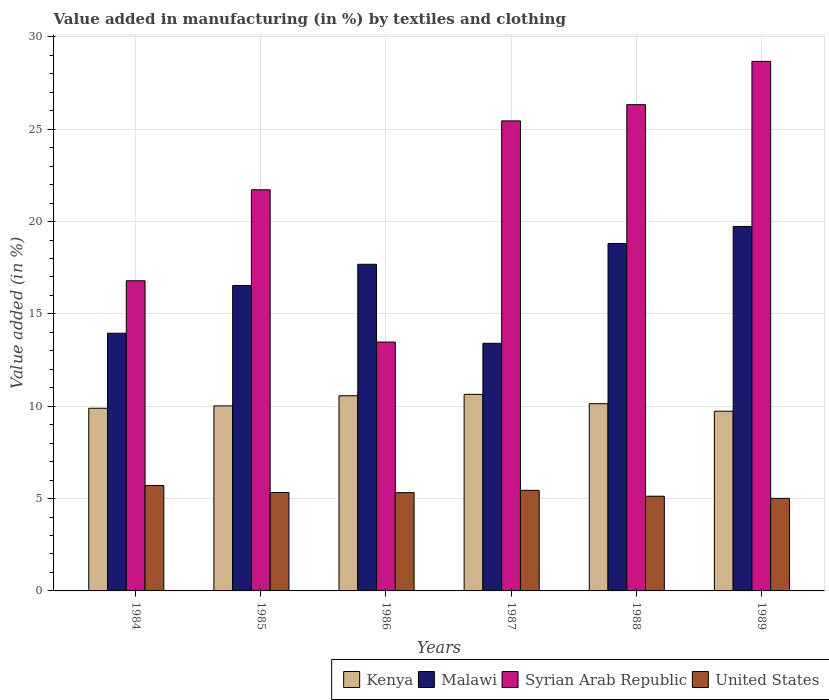How many different coloured bars are there?
Your answer should be very brief. 4. Are the number of bars per tick equal to the number of legend labels?
Your answer should be very brief. Yes. How many bars are there on the 4th tick from the left?
Provide a short and direct response. 4. How many bars are there on the 3rd tick from the right?
Your answer should be very brief. 4. What is the label of the 2nd group of bars from the left?
Provide a short and direct response. 1985. What is the percentage of value added in manufacturing by textiles and clothing in Malawi in 1987?
Your answer should be compact. 13.41. Across all years, what is the maximum percentage of value added in manufacturing by textiles and clothing in United States?
Offer a very short reply. 5.71. Across all years, what is the minimum percentage of value added in manufacturing by textiles and clothing in United States?
Provide a succinct answer. 5.01. In which year was the percentage of value added in manufacturing by textiles and clothing in Syrian Arab Republic maximum?
Give a very brief answer. 1989. In which year was the percentage of value added in manufacturing by textiles and clothing in Malawi minimum?
Offer a very short reply. 1987. What is the total percentage of value added in manufacturing by textiles and clothing in Malawi in the graph?
Ensure brevity in your answer.  100.14. What is the difference between the percentage of value added in manufacturing by textiles and clothing in United States in 1987 and that in 1988?
Ensure brevity in your answer.  0.32. What is the difference between the percentage of value added in manufacturing by textiles and clothing in Syrian Arab Republic in 1987 and the percentage of value added in manufacturing by textiles and clothing in Malawi in 1985?
Offer a terse response. 8.92. What is the average percentage of value added in manufacturing by textiles and clothing in Syrian Arab Republic per year?
Your answer should be very brief. 22.08. In the year 1985, what is the difference between the percentage of value added in manufacturing by textiles and clothing in Syrian Arab Republic and percentage of value added in manufacturing by textiles and clothing in United States?
Your answer should be compact. 16.39. In how many years, is the percentage of value added in manufacturing by textiles and clothing in Kenya greater than 26 %?
Offer a terse response. 0. What is the ratio of the percentage of value added in manufacturing by textiles and clothing in Kenya in 1986 to that in 1987?
Offer a terse response. 0.99. Is the difference between the percentage of value added in manufacturing by textiles and clothing in Syrian Arab Republic in 1984 and 1989 greater than the difference between the percentage of value added in manufacturing by textiles and clothing in United States in 1984 and 1989?
Your response must be concise. No. What is the difference between the highest and the second highest percentage of value added in manufacturing by textiles and clothing in Kenya?
Keep it short and to the point. 0.07. What is the difference between the highest and the lowest percentage of value added in manufacturing by textiles and clothing in Malawi?
Provide a succinct answer. 6.33. In how many years, is the percentage of value added in manufacturing by textiles and clothing in Kenya greater than the average percentage of value added in manufacturing by textiles and clothing in Kenya taken over all years?
Offer a very short reply. 2. Is the sum of the percentage of value added in manufacturing by textiles and clothing in Kenya in 1984 and 1988 greater than the maximum percentage of value added in manufacturing by textiles and clothing in Malawi across all years?
Provide a short and direct response. Yes. Is it the case that in every year, the sum of the percentage of value added in manufacturing by textiles and clothing in Kenya and percentage of value added in manufacturing by textiles and clothing in United States is greater than the sum of percentage of value added in manufacturing by textiles and clothing in Syrian Arab Republic and percentage of value added in manufacturing by textiles and clothing in Malawi?
Make the answer very short. Yes. What does the 2nd bar from the left in 1985 represents?
Your response must be concise. Malawi. What does the 3rd bar from the right in 1984 represents?
Keep it short and to the point. Malawi. Are all the bars in the graph horizontal?
Provide a short and direct response. No. How many years are there in the graph?
Your answer should be compact. 6. What is the difference between two consecutive major ticks on the Y-axis?
Provide a succinct answer. 5. Does the graph contain grids?
Offer a very short reply. Yes. How many legend labels are there?
Give a very brief answer. 4. How are the legend labels stacked?
Make the answer very short. Horizontal. What is the title of the graph?
Provide a short and direct response. Value added in manufacturing (in %) by textiles and clothing. What is the label or title of the X-axis?
Provide a short and direct response. Years. What is the label or title of the Y-axis?
Offer a very short reply. Value added (in %). What is the Value added (in %) of Kenya in 1984?
Ensure brevity in your answer.  9.89. What is the Value added (in %) in Malawi in 1984?
Your answer should be compact. 13.95. What is the Value added (in %) of Syrian Arab Republic in 1984?
Keep it short and to the point. 16.8. What is the Value added (in %) in United States in 1984?
Keep it short and to the point. 5.71. What is the Value added (in %) in Kenya in 1985?
Offer a terse response. 10.02. What is the Value added (in %) in Malawi in 1985?
Your answer should be compact. 16.54. What is the Value added (in %) of Syrian Arab Republic in 1985?
Keep it short and to the point. 21.72. What is the Value added (in %) in United States in 1985?
Ensure brevity in your answer.  5.33. What is the Value added (in %) of Kenya in 1986?
Your answer should be very brief. 10.57. What is the Value added (in %) of Malawi in 1986?
Your answer should be compact. 17.69. What is the Value added (in %) of Syrian Arab Republic in 1986?
Provide a succinct answer. 13.48. What is the Value added (in %) in United States in 1986?
Ensure brevity in your answer.  5.32. What is the Value added (in %) of Kenya in 1987?
Provide a succinct answer. 10.64. What is the Value added (in %) of Malawi in 1987?
Make the answer very short. 13.41. What is the Value added (in %) in Syrian Arab Republic in 1987?
Ensure brevity in your answer.  25.45. What is the Value added (in %) in United States in 1987?
Ensure brevity in your answer.  5.45. What is the Value added (in %) of Kenya in 1988?
Keep it short and to the point. 10.14. What is the Value added (in %) in Malawi in 1988?
Provide a short and direct response. 18.81. What is the Value added (in %) in Syrian Arab Republic in 1988?
Give a very brief answer. 26.33. What is the Value added (in %) of United States in 1988?
Ensure brevity in your answer.  5.13. What is the Value added (in %) in Kenya in 1989?
Ensure brevity in your answer.  9.73. What is the Value added (in %) of Malawi in 1989?
Your answer should be very brief. 19.74. What is the Value added (in %) in Syrian Arab Republic in 1989?
Your answer should be very brief. 28.68. What is the Value added (in %) of United States in 1989?
Keep it short and to the point. 5.01. Across all years, what is the maximum Value added (in %) of Kenya?
Give a very brief answer. 10.64. Across all years, what is the maximum Value added (in %) in Malawi?
Provide a short and direct response. 19.74. Across all years, what is the maximum Value added (in %) of Syrian Arab Republic?
Give a very brief answer. 28.68. Across all years, what is the maximum Value added (in %) of United States?
Your answer should be very brief. 5.71. Across all years, what is the minimum Value added (in %) of Kenya?
Give a very brief answer. 9.73. Across all years, what is the minimum Value added (in %) of Malawi?
Make the answer very short. 13.41. Across all years, what is the minimum Value added (in %) in Syrian Arab Republic?
Provide a succinct answer. 13.48. Across all years, what is the minimum Value added (in %) of United States?
Provide a short and direct response. 5.01. What is the total Value added (in %) of Kenya in the graph?
Your response must be concise. 60.99. What is the total Value added (in %) of Malawi in the graph?
Make the answer very short. 100.14. What is the total Value added (in %) in Syrian Arab Republic in the graph?
Make the answer very short. 132.45. What is the total Value added (in %) in United States in the graph?
Ensure brevity in your answer.  31.95. What is the difference between the Value added (in %) in Kenya in 1984 and that in 1985?
Your response must be concise. -0.13. What is the difference between the Value added (in %) in Malawi in 1984 and that in 1985?
Keep it short and to the point. -2.58. What is the difference between the Value added (in %) in Syrian Arab Republic in 1984 and that in 1985?
Provide a short and direct response. -4.93. What is the difference between the Value added (in %) in United States in 1984 and that in 1985?
Your answer should be compact. 0.38. What is the difference between the Value added (in %) of Kenya in 1984 and that in 1986?
Offer a very short reply. -0.68. What is the difference between the Value added (in %) of Malawi in 1984 and that in 1986?
Your answer should be very brief. -3.73. What is the difference between the Value added (in %) in Syrian Arab Republic in 1984 and that in 1986?
Keep it short and to the point. 3.32. What is the difference between the Value added (in %) in United States in 1984 and that in 1986?
Your response must be concise. 0.39. What is the difference between the Value added (in %) in Kenya in 1984 and that in 1987?
Your answer should be compact. -0.75. What is the difference between the Value added (in %) of Malawi in 1984 and that in 1987?
Provide a short and direct response. 0.55. What is the difference between the Value added (in %) in Syrian Arab Republic in 1984 and that in 1987?
Your answer should be compact. -8.66. What is the difference between the Value added (in %) in United States in 1984 and that in 1987?
Your answer should be compact. 0.26. What is the difference between the Value added (in %) of Kenya in 1984 and that in 1988?
Make the answer very short. -0.25. What is the difference between the Value added (in %) in Malawi in 1984 and that in 1988?
Make the answer very short. -4.86. What is the difference between the Value added (in %) in Syrian Arab Republic in 1984 and that in 1988?
Your answer should be compact. -9.53. What is the difference between the Value added (in %) in United States in 1984 and that in 1988?
Make the answer very short. 0.58. What is the difference between the Value added (in %) in Kenya in 1984 and that in 1989?
Give a very brief answer. 0.16. What is the difference between the Value added (in %) in Malawi in 1984 and that in 1989?
Ensure brevity in your answer.  -5.78. What is the difference between the Value added (in %) in Syrian Arab Republic in 1984 and that in 1989?
Your answer should be compact. -11.88. What is the difference between the Value added (in %) in United States in 1984 and that in 1989?
Offer a very short reply. 0.7. What is the difference between the Value added (in %) of Kenya in 1985 and that in 1986?
Keep it short and to the point. -0.55. What is the difference between the Value added (in %) in Malawi in 1985 and that in 1986?
Offer a terse response. -1.15. What is the difference between the Value added (in %) in Syrian Arab Republic in 1985 and that in 1986?
Keep it short and to the point. 8.24. What is the difference between the Value added (in %) of United States in 1985 and that in 1986?
Offer a terse response. 0.01. What is the difference between the Value added (in %) in Kenya in 1985 and that in 1987?
Offer a terse response. -0.62. What is the difference between the Value added (in %) in Malawi in 1985 and that in 1987?
Ensure brevity in your answer.  3.13. What is the difference between the Value added (in %) of Syrian Arab Republic in 1985 and that in 1987?
Keep it short and to the point. -3.73. What is the difference between the Value added (in %) of United States in 1985 and that in 1987?
Keep it short and to the point. -0.12. What is the difference between the Value added (in %) of Kenya in 1985 and that in 1988?
Make the answer very short. -0.12. What is the difference between the Value added (in %) of Malawi in 1985 and that in 1988?
Offer a very short reply. -2.28. What is the difference between the Value added (in %) in Syrian Arab Republic in 1985 and that in 1988?
Your answer should be compact. -4.61. What is the difference between the Value added (in %) in United States in 1985 and that in 1988?
Keep it short and to the point. 0.2. What is the difference between the Value added (in %) in Kenya in 1985 and that in 1989?
Your response must be concise. 0.29. What is the difference between the Value added (in %) in Malawi in 1985 and that in 1989?
Your answer should be compact. -3.2. What is the difference between the Value added (in %) of Syrian Arab Republic in 1985 and that in 1989?
Ensure brevity in your answer.  -6.96. What is the difference between the Value added (in %) of United States in 1985 and that in 1989?
Your answer should be very brief. 0.32. What is the difference between the Value added (in %) in Kenya in 1986 and that in 1987?
Provide a succinct answer. -0.07. What is the difference between the Value added (in %) in Malawi in 1986 and that in 1987?
Provide a succinct answer. 4.28. What is the difference between the Value added (in %) of Syrian Arab Republic in 1986 and that in 1987?
Offer a terse response. -11.98. What is the difference between the Value added (in %) in United States in 1986 and that in 1987?
Provide a short and direct response. -0.13. What is the difference between the Value added (in %) in Kenya in 1986 and that in 1988?
Give a very brief answer. 0.43. What is the difference between the Value added (in %) of Malawi in 1986 and that in 1988?
Keep it short and to the point. -1.13. What is the difference between the Value added (in %) of Syrian Arab Republic in 1986 and that in 1988?
Your answer should be very brief. -12.85. What is the difference between the Value added (in %) of United States in 1986 and that in 1988?
Provide a succinct answer. 0.19. What is the difference between the Value added (in %) in Kenya in 1986 and that in 1989?
Give a very brief answer. 0.84. What is the difference between the Value added (in %) of Malawi in 1986 and that in 1989?
Offer a very short reply. -2.05. What is the difference between the Value added (in %) in Syrian Arab Republic in 1986 and that in 1989?
Your response must be concise. -15.2. What is the difference between the Value added (in %) in United States in 1986 and that in 1989?
Your answer should be very brief. 0.31. What is the difference between the Value added (in %) in Kenya in 1987 and that in 1988?
Provide a short and direct response. 0.51. What is the difference between the Value added (in %) of Malawi in 1987 and that in 1988?
Ensure brevity in your answer.  -5.4. What is the difference between the Value added (in %) of Syrian Arab Republic in 1987 and that in 1988?
Keep it short and to the point. -0.88. What is the difference between the Value added (in %) of United States in 1987 and that in 1988?
Give a very brief answer. 0.32. What is the difference between the Value added (in %) of Kenya in 1987 and that in 1989?
Provide a short and direct response. 0.91. What is the difference between the Value added (in %) of Malawi in 1987 and that in 1989?
Keep it short and to the point. -6.33. What is the difference between the Value added (in %) of Syrian Arab Republic in 1987 and that in 1989?
Your answer should be compact. -3.22. What is the difference between the Value added (in %) in United States in 1987 and that in 1989?
Offer a terse response. 0.43. What is the difference between the Value added (in %) in Kenya in 1988 and that in 1989?
Your response must be concise. 0.41. What is the difference between the Value added (in %) in Malawi in 1988 and that in 1989?
Your answer should be very brief. -0.92. What is the difference between the Value added (in %) of Syrian Arab Republic in 1988 and that in 1989?
Give a very brief answer. -2.35. What is the difference between the Value added (in %) of United States in 1988 and that in 1989?
Make the answer very short. 0.12. What is the difference between the Value added (in %) in Kenya in 1984 and the Value added (in %) in Malawi in 1985?
Provide a succinct answer. -6.65. What is the difference between the Value added (in %) in Kenya in 1984 and the Value added (in %) in Syrian Arab Republic in 1985?
Your answer should be very brief. -11.83. What is the difference between the Value added (in %) of Kenya in 1984 and the Value added (in %) of United States in 1985?
Your answer should be very brief. 4.56. What is the difference between the Value added (in %) in Malawi in 1984 and the Value added (in %) in Syrian Arab Republic in 1985?
Provide a short and direct response. -7.77. What is the difference between the Value added (in %) in Malawi in 1984 and the Value added (in %) in United States in 1985?
Your answer should be compact. 8.62. What is the difference between the Value added (in %) of Syrian Arab Republic in 1984 and the Value added (in %) of United States in 1985?
Your response must be concise. 11.47. What is the difference between the Value added (in %) in Kenya in 1984 and the Value added (in %) in Malawi in 1986?
Ensure brevity in your answer.  -7.8. What is the difference between the Value added (in %) of Kenya in 1984 and the Value added (in %) of Syrian Arab Republic in 1986?
Your answer should be compact. -3.58. What is the difference between the Value added (in %) of Kenya in 1984 and the Value added (in %) of United States in 1986?
Provide a short and direct response. 4.57. What is the difference between the Value added (in %) in Malawi in 1984 and the Value added (in %) in Syrian Arab Republic in 1986?
Make the answer very short. 0.48. What is the difference between the Value added (in %) in Malawi in 1984 and the Value added (in %) in United States in 1986?
Ensure brevity in your answer.  8.63. What is the difference between the Value added (in %) in Syrian Arab Republic in 1984 and the Value added (in %) in United States in 1986?
Keep it short and to the point. 11.48. What is the difference between the Value added (in %) of Kenya in 1984 and the Value added (in %) of Malawi in 1987?
Your response must be concise. -3.52. What is the difference between the Value added (in %) of Kenya in 1984 and the Value added (in %) of Syrian Arab Republic in 1987?
Give a very brief answer. -15.56. What is the difference between the Value added (in %) of Kenya in 1984 and the Value added (in %) of United States in 1987?
Offer a very short reply. 4.45. What is the difference between the Value added (in %) in Malawi in 1984 and the Value added (in %) in Syrian Arab Republic in 1987?
Offer a terse response. -11.5. What is the difference between the Value added (in %) in Malawi in 1984 and the Value added (in %) in United States in 1987?
Keep it short and to the point. 8.51. What is the difference between the Value added (in %) of Syrian Arab Republic in 1984 and the Value added (in %) of United States in 1987?
Offer a terse response. 11.35. What is the difference between the Value added (in %) in Kenya in 1984 and the Value added (in %) in Malawi in 1988?
Provide a succinct answer. -8.92. What is the difference between the Value added (in %) in Kenya in 1984 and the Value added (in %) in Syrian Arab Republic in 1988?
Your answer should be very brief. -16.44. What is the difference between the Value added (in %) of Kenya in 1984 and the Value added (in %) of United States in 1988?
Your response must be concise. 4.76. What is the difference between the Value added (in %) of Malawi in 1984 and the Value added (in %) of Syrian Arab Republic in 1988?
Offer a terse response. -12.38. What is the difference between the Value added (in %) of Malawi in 1984 and the Value added (in %) of United States in 1988?
Offer a terse response. 8.83. What is the difference between the Value added (in %) in Syrian Arab Republic in 1984 and the Value added (in %) in United States in 1988?
Ensure brevity in your answer.  11.67. What is the difference between the Value added (in %) in Kenya in 1984 and the Value added (in %) in Malawi in 1989?
Give a very brief answer. -9.84. What is the difference between the Value added (in %) in Kenya in 1984 and the Value added (in %) in Syrian Arab Republic in 1989?
Keep it short and to the point. -18.78. What is the difference between the Value added (in %) in Kenya in 1984 and the Value added (in %) in United States in 1989?
Ensure brevity in your answer.  4.88. What is the difference between the Value added (in %) in Malawi in 1984 and the Value added (in %) in Syrian Arab Republic in 1989?
Your response must be concise. -14.72. What is the difference between the Value added (in %) of Malawi in 1984 and the Value added (in %) of United States in 1989?
Offer a terse response. 8.94. What is the difference between the Value added (in %) of Syrian Arab Republic in 1984 and the Value added (in %) of United States in 1989?
Keep it short and to the point. 11.78. What is the difference between the Value added (in %) in Kenya in 1985 and the Value added (in %) in Malawi in 1986?
Give a very brief answer. -7.67. What is the difference between the Value added (in %) of Kenya in 1985 and the Value added (in %) of Syrian Arab Republic in 1986?
Offer a very short reply. -3.46. What is the difference between the Value added (in %) in Kenya in 1985 and the Value added (in %) in United States in 1986?
Offer a terse response. 4.7. What is the difference between the Value added (in %) in Malawi in 1985 and the Value added (in %) in Syrian Arab Republic in 1986?
Make the answer very short. 3.06. What is the difference between the Value added (in %) in Malawi in 1985 and the Value added (in %) in United States in 1986?
Offer a terse response. 11.22. What is the difference between the Value added (in %) of Syrian Arab Republic in 1985 and the Value added (in %) of United States in 1986?
Your answer should be very brief. 16.4. What is the difference between the Value added (in %) in Kenya in 1985 and the Value added (in %) in Malawi in 1987?
Provide a short and direct response. -3.39. What is the difference between the Value added (in %) in Kenya in 1985 and the Value added (in %) in Syrian Arab Republic in 1987?
Ensure brevity in your answer.  -15.43. What is the difference between the Value added (in %) in Kenya in 1985 and the Value added (in %) in United States in 1987?
Provide a succinct answer. 4.57. What is the difference between the Value added (in %) of Malawi in 1985 and the Value added (in %) of Syrian Arab Republic in 1987?
Offer a very short reply. -8.92. What is the difference between the Value added (in %) of Malawi in 1985 and the Value added (in %) of United States in 1987?
Your response must be concise. 11.09. What is the difference between the Value added (in %) of Syrian Arab Republic in 1985 and the Value added (in %) of United States in 1987?
Your answer should be very brief. 16.28. What is the difference between the Value added (in %) of Kenya in 1985 and the Value added (in %) of Malawi in 1988?
Offer a terse response. -8.79. What is the difference between the Value added (in %) of Kenya in 1985 and the Value added (in %) of Syrian Arab Republic in 1988?
Offer a terse response. -16.31. What is the difference between the Value added (in %) of Kenya in 1985 and the Value added (in %) of United States in 1988?
Your answer should be compact. 4.89. What is the difference between the Value added (in %) of Malawi in 1985 and the Value added (in %) of Syrian Arab Republic in 1988?
Your answer should be compact. -9.79. What is the difference between the Value added (in %) in Malawi in 1985 and the Value added (in %) in United States in 1988?
Your answer should be very brief. 11.41. What is the difference between the Value added (in %) of Syrian Arab Republic in 1985 and the Value added (in %) of United States in 1988?
Your response must be concise. 16.59. What is the difference between the Value added (in %) in Kenya in 1985 and the Value added (in %) in Malawi in 1989?
Give a very brief answer. -9.72. What is the difference between the Value added (in %) of Kenya in 1985 and the Value added (in %) of Syrian Arab Republic in 1989?
Keep it short and to the point. -18.66. What is the difference between the Value added (in %) of Kenya in 1985 and the Value added (in %) of United States in 1989?
Provide a short and direct response. 5.01. What is the difference between the Value added (in %) in Malawi in 1985 and the Value added (in %) in Syrian Arab Republic in 1989?
Provide a short and direct response. -12.14. What is the difference between the Value added (in %) in Malawi in 1985 and the Value added (in %) in United States in 1989?
Your answer should be compact. 11.53. What is the difference between the Value added (in %) of Syrian Arab Republic in 1985 and the Value added (in %) of United States in 1989?
Offer a very short reply. 16.71. What is the difference between the Value added (in %) in Kenya in 1986 and the Value added (in %) in Malawi in 1987?
Make the answer very short. -2.84. What is the difference between the Value added (in %) in Kenya in 1986 and the Value added (in %) in Syrian Arab Republic in 1987?
Your answer should be compact. -14.88. What is the difference between the Value added (in %) in Kenya in 1986 and the Value added (in %) in United States in 1987?
Your response must be concise. 5.12. What is the difference between the Value added (in %) in Malawi in 1986 and the Value added (in %) in Syrian Arab Republic in 1987?
Your answer should be compact. -7.77. What is the difference between the Value added (in %) in Malawi in 1986 and the Value added (in %) in United States in 1987?
Your answer should be very brief. 12.24. What is the difference between the Value added (in %) in Syrian Arab Republic in 1986 and the Value added (in %) in United States in 1987?
Your response must be concise. 8.03. What is the difference between the Value added (in %) of Kenya in 1986 and the Value added (in %) of Malawi in 1988?
Give a very brief answer. -8.24. What is the difference between the Value added (in %) of Kenya in 1986 and the Value added (in %) of Syrian Arab Republic in 1988?
Your answer should be very brief. -15.76. What is the difference between the Value added (in %) of Kenya in 1986 and the Value added (in %) of United States in 1988?
Your response must be concise. 5.44. What is the difference between the Value added (in %) in Malawi in 1986 and the Value added (in %) in Syrian Arab Republic in 1988?
Ensure brevity in your answer.  -8.64. What is the difference between the Value added (in %) in Malawi in 1986 and the Value added (in %) in United States in 1988?
Provide a succinct answer. 12.56. What is the difference between the Value added (in %) of Syrian Arab Republic in 1986 and the Value added (in %) of United States in 1988?
Provide a succinct answer. 8.35. What is the difference between the Value added (in %) in Kenya in 1986 and the Value added (in %) in Malawi in 1989?
Ensure brevity in your answer.  -9.17. What is the difference between the Value added (in %) of Kenya in 1986 and the Value added (in %) of Syrian Arab Republic in 1989?
Provide a short and direct response. -18.11. What is the difference between the Value added (in %) of Kenya in 1986 and the Value added (in %) of United States in 1989?
Offer a terse response. 5.56. What is the difference between the Value added (in %) of Malawi in 1986 and the Value added (in %) of Syrian Arab Republic in 1989?
Keep it short and to the point. -10.99. What is the difference between the Value added (in %) in Malawi in 1986 and the Value added (in %) in United States in 1989?
Provide a succinct answer. 12.68. What is the difference between the Value added (in %) of Syrian Arab Republic in 1986 and the Value added (in %) of United States in 1989?
Give a very brief answer. 8.46. What is the difference between the Value added (in %) in Kenya in 1987 and the Value added (in %) in Malawi in 1988?
Ensure brevity in your answer.  -8.17. What is the difference between the Value added (in %) in Kenya in 1987 and the Value added (in %) in Syrian Arab Republic in 1988?
Provide a short and direct response. -15.69. What is the difference between the Value added (in %) of Kenya in 1987 and the Value added (in %) of United States in 1988?
Your answer should be compact. 5.51. What is the difference between the Value added (in %) in Malawi in 1987 and the Value added (in %) in Syrian Arab Republic in 1988?
Offer a terse response. -12.92. What is the difference between the Value added (in %) of Malawi in 1987 and the Value added (in %) of United States in 1988?
Your answer should be compact. 8.28. What is the difference between the Value added (in %) in Syrian Arab Republic in 1987 and the Value added (in %) in United States in 1988?
Provide a succinct answer. 20.32. What is the difference between the Value added (in %) in Kenya in 1987 and the Value added (in %) in Malawi in 1989?
Provide a short and direct response. -9.09. What is the difference between the Value added (in %) of Kenya in 1987 and the Value added (in %) of Syrian Arab Republic in 1989?
Provide a succinct answer. -18.03. What is the difference between the Value added (in %) in Kenya in 1987 and the Value added (in %) in United States in 1989?
Provide a succinct answer. 5.63. What is the difference between the Value added (in %) of Malawi in 1987 and the Value added (in %) of Syrian Arab Republic in 1989?
Your answer should be very brief. -15.27. What is the difference between the Value added (in %) of Malawi in 1987 and the Value added (in %) of United States in 1989?
Offer a terse response. 8.4. What is the difference between the Value added (in %) in Syrian Arab Republic in 1987 and the Value added (in %) in United States in 1989?
Offer a very short reply. 20.44. What is the difference between the Value added (in %) of Kenya in 1988 and the Value added (in %) of Malawi in 1989?
Ensure brevity in your answer.  -9.6. What is the difference between the Value added (in %) of Kenya in 1988 and the Value added (in %) of Syrian Arab Republic in 1989?
Provide a succinct answer. -18.54. What is the difference between the Value added (in %) of Kenya in 1988 and the Value added (in %) of United States in 1989?
Provide a succinct answer. 5.13. What is the difference between the Value added (in %) of Malawi in 1988 and the Value added (in %) of Syrian Arab Republic in 1989?
Provide a short and direct response. -9.86. What is the difference between the Value added (in %) of Malawi in 1988 and the Value added (in %) of United States in 1989?
Keep it short and to the point. 13.8. What is the difference between the Value added (in %) of Syrian Arab Republic in 1988 and the Value added (in %) of United States in 1989?
Make the answer very short. 21.32. What is the average Value added (in %) of Kenya per year?
Offer a very short reply. 10.17. What is the average Value added (in %) of Malawi per year?
Your answer should be compact. 16.69. What is the average Value added (in %) of Syrian Arab Republic per year?
Your response must be concise. 22.08. What is the average Value added (in %) of United States per year?
Your response must be concise. 5.32. In the year 1984, what is the difference between the Value added (in %) in Kenya and Value added (in %) in Malawi?
Your answer should be compact. -4.06. In the year 1984, what is the difference between the Value added (in %) in Kenya and Value added (in %) in Syrian Arab Republic?
Ensure brevity in your answer.  -6.9. In the year 1984, what is the difference between the Value added (in %) of Kenya and Value added (in %) of United States?
Make the answer very short. 4.18. In the year 1984, what is the difference between the Value added (in %) in Malawi and Value added (in %) in Syrian Arab Republic?
Provide a succinct answer. -2.84. In the year 1984, what is the difference between the Value added (in %) of Malawi and Value added (in %) of United States?
Provide a short and direct response. 8.25. In the year 1984, what is the difference between the Value added (in %) of Syrian Arab Republic and Value added (in %) of United States?
Provide a succinct answer. 11.09. In the year 1985, what is the difference between the Value added (in %) in Kenya and Value added (in %) in Malawi?
Make the answer very short. -6.52. In the year 1985, what is the difference between the Value added (in %) of Kenya and Value added (in %) of Syrian Arab Republic?
Offer a very short reply. -11.7. In the year 1985, what is the difference between the Value added (in %) in Kenya and Value added (in %) in United States?
Ensure brevity in your answer.  4.69. In the year 1985, what is the difference between the Value added (in %) in Malawi and Value added (in %) in Syrian Arab Republic?
Provide a succinct answer. -5.18. In the year 1985, what is the difference between the Value added (in %) in Malawi and Value added (in %) in United States?
Make the answer very short. 11.21. In the year 1985, what is the difference between the Value added (in %) of Syrian Arab Republic and Value added (in %) of United States?
Make the answer very short. 16.39. In the year 1986, what is the difference between the Value added (in %) in Kenya and Value added (in %) in Malawi?
Keep it short and to the point. -7.12. In the year 1986, what is the difference between the Value added (in %) of Kenya and Value added (in %) of Syrian Arab Republic?
Offer a terse response. -2.91. In the year 1986, what is the difference between the Value added (in %) in Kenya and Value added (in %) in United States?
Offer a terse response. 5.25. In the year 1986, what is the difference between the Value added (in %) of Malawi and Value added (in %) of Syrian Arab Republic?
Provide a succinct answer. 4.21. In the year 1986, what is the difference between the Value added (in %) of Malawi and Value added (in %) of United States?
Give a very brief answer. 12.37. In the year 1986, what is the difference between the Value added (in %) of Syrian Arab Republic and Value added (in %) of United States?
Your answer should be very brief. 8.16. In the year 1987, what is the difference between the Value added (in %) in Kenya and Value added (in %) in Malawi?
Keep it short and to the point. -2.77. In the year 1987, what is the difference between the Value added (in %) in Kenya and Value added (in %) in Syrian Arab Republic?
Make the answer very short. -14.81. In the year 1987, what is the difference between the Value added (in %) of Kenya and Value added (in %) of United States?
Your answer should be compact. 5.2. In the year 1987, what is the difference between the Value added (in %) in Malawi and Value added (in %) in Syrian Arab Republic?
Offer a very short reply. -12.04. In the year 1987, what is the difference between the Value added (in %) of Malawi and Value added (in %) of United States?
Provide a succinct answer. 7.96. In the year 1987, what is the difference between the Value added (in %) in Syrian Arab Republic and Value added (in %) in United States?
Ensure brevity in your answer.  20.01. In the year 1988, what is the difference between the Value added (in %) in Kenya and Value added (in %) in Malawi?
Your answer should be very brief. -8.68. In the year 1988, what is the difference between the Value added (in %) in Kenya and Value added (in %) in Syrian Arab Republic?
Ensure brevity in your answer.  -16.19. In the year 1988, what is the difference between the Value added (in %) of Kenya and Value added (in %) of United States?
Your answer should be very brief. 5.01. In the year 1988, what is the difference between the Value added (in %) of Malawi and Value added (in %) of Syrian Arab Republic?
Offer a very short reply. -7.52. In the year 1988, what is the difference between the Value added (in %) in Malawi and Value added (in %) in United States?
Offer a terse response. 13.69. In the year 1988, what is the difference between the Value added (in %) in Syrian Arab Republic and Value added (in %) in United States?
Your response must be concise. 21.2. In the year 1989, what is the difference between the Value added (in %) in Kenya and Value added (in %) in Malawi?
Make the answer very short. -10. In the year 1989, what is the difference between the Value added (in %) of Kenya and Value added (in %) of Syrian Arab Republic?
Ensure brevity in your answer.  -18.95. In the year 1989, what is the difference between the Value added (in %) in Kenya and Value added (in %) in United States?
Your answer should be compact. 4.72. In the year 1989, what is the difference between the Value added (in %) of Malawi and Value added (in %) of Syrian Arab Republic?
Your answer should be compact. -8.94. In the year 1989, what is the difference between the Value added (in %) of Malawi and Value added (in %) of United States?
Provide a succinct answer. 14.72. In the year 1989, what is the difference between the Value added (in %) in Syrian Arab Republic and Value added (in %) in United States?
Keep it short and to the point. 23.66. What is the ratio of the Value added (in %) in Kenya in 1984 to that in 1985?
Give a very brief answer. 0.99. What is the ratio of the Value added (in %) of Malawi in 1984 to that in 1985?
Ensure brevity in your answer.  0.84. What is the ratio of the Value added (in %) of Syrian Arab Republic in 1984 to that in 1985?
Make the answer very short. 0.77. What is the ratio of the Value added (in %) in United States in 1984 to that in 1985?
Make the answer very short. 1.07. What is the ratio of the Value added (in %) in Kenya in 1984 to that in 1986?
Make the answer very short. 0.94. What is the ratio of the Value added (in %) of Malawi in 1984 to that in 1986?
Give a very brief answer. 0.79. What is the ratio of the Value added (in %) in Syrian Arab Republic in 1984 to that in 1986?
Provide a succinct answer. 1.25. What is the ratio of the Value added (in %) in United States in 1984 to that in 1986?
Make the answer very short. 1.07. What is the ratio of the Value added (in %) in Kenya in 1984 to that in 1987?
Offer a very short reply. 0.93. What is the ratio of the Value added (in %) of Malawi in 1984 to that in 1987?
Provide a succinct answer. 1.04. What is the ratio of the Value added (in %) in Syrian Arab Republic in 1984 to that in 1987?
Keep it short and to the point. 0.66. What is the ratio of the Value added (in %) in United States in 1984 to that in 1987?
Make the answer very short. 1.05. What is the ratio of the Value added (in %) of Kenya in 1984 to that in 1988?
Keep it short and to the point. 0.98. What is the ratio of the Value added (in %) of Malawi in 1984 to that in 1988?
Your answer should be compact. 0.74. What is the ratio of the Value added (in %) in Syrian Arab Republic in 1984 to that in 1988?
Ensure brevity in your answer.  0.64. What is the ratio of the Value added (in %) of United States in 1984 to that in 1988?
Give a very brief answer. 1.11. What is the ratio of the Value added (in %) in Kenya in 1984 to that in 1989?
Offer a very short reply. 1.02. What is the ratio of the Value added (in %) in Malawi in 1984 to that in 1989?
Offer a terse response. 0.71. What is the ratio of the Value added (in %) of Syrian Arab Republic in 1984 to that in 1989?
Offer a terse response. 0.59. What is the ratio of the Value added (in %) of United States in 1984 to that in 1989?
Keep it short and to the point. 1.14. What is the ratio of the Value added (in %) of Kenya in 1985 to that in 1986?
Your answer should be compact. 0.95. What is the ratio of the Value added (in %) of Malawi in 1985 to that in 1986?
Provide a short and direct response. 0.94. What is the ratio of the Value added (in %) in Syrian Arab Republic in 1985 to that in 1986?
Offer a terse response. 1.61. What is the ratio of the Value added (in %) in Kenya in 1985 to that in 1987?
Your answer should be very brief. 0.94. What is the ratio of the Value added (in %) in Malawi in 1985 to that in 1987?
Ensure brevity in your answer.  1.23. What is the ratio of the Value added (in %) in Syrian Arab Republic in 1985 to that in 1987?
Offer a very short reply. 0.85. What is the ratio of the Value added (in %) of United States in 1985 to that in 1987?
Your answer should be very brief. 0.98. What is the ratio of the Value added (in %) of Kenya in 1985 to that in 1988?
Offer a terse response. 0.99. What is the ratio of the Value added (in %) of Malawi in 1985 to that in 1988?
Your answer should be compact. 0.88. What is the ratio of the Value added (in %) in Syrian Arab Republic in 1985 to that in 1988?
Provide a short and direct response. 0.82. What is the ratio of the Value added (in %) in United States in 1985 to that in 1988?
Your answer should be compact. 1.04. What is the ratio of the Value added (in %) in Kenya in 1985 to that in 1989?
Your answer should be compact. 1.03. What is the ratio of the Value added (in %) in Malawi in 1985 to that in 1989?
Give a very brief answer. 0.84. What is the ratio of the Value added (in %) in Syrian Arab Republic in 1985 to that in 1989?
Your answer should be compact. 0.76. What is the ratio of the Value added (in %) of United States in 1985 to that in 1989?
Ensure brevity in your answer.  1.06. What is the ratio of the Value added (in %) in Kenya in 1986 to that in 1987?
Your answer should be compact. 0.99. What is the ratio of the Value added (in %) in Malawi in 1986 to that in 1987?
Provide a short and direct response. 1.32. What is the ratio of the Value added (in %) in Syrian Arab Republic in 1986 to that in 1987?
Keep it short and to the point. 0.53. What is the ratio of the Value added (in %) in United States in 1986 to that in 1987?
Ensure brevity in your answer.  0.98. What is the ratio of the Value added (in %) of Kenya in 1986 to that in 1988?
Keep it short and to the point. 1.04. What is the ratio of the Value added (in %) of Malawi in 1986 to that in 1988?
Provide a succinct answer. 0.94. What is the ratio of the Value added (in %) of Syrian Arab Republic in 1986 to that in 1988?
Provide a short and direct response. 0.51. What is the ratio of the Value added (in %) in United States in 1986 to that in 1988?
Your response must be concise. 1.04. What is the ratio of the Value added (in %) of Kenya in 1986 to that in 1989?
Give a very brief answer. 1.09. What is the ratio of the Value added (in %) in Malawi in 1986 to that in 1989?
Ensure brevity in your answer.  0.9. What is the ratio of the Value added (in %) in Syrian Arab Republic in 1986 to that in 1989?
Offer a very short reply. 0.47. What is the ratio of the Value added (in %) of United States in 1986 to that in 1989?
Your response must be concise. 1.06. What is the ratio of the Value added (in %) in Kenya in 1987 to that in 1988?
Your answer should be very brief. 1.05. What is the ratio of the Value added (in %) of Malawi in 1987 to that in 1988?
Make the answer very short. 0.71. What is the ratio of the Value added (in %) in Syrian Arab Republic in 1987 to that in 1988?
Your answer should be very brief. 0.97. What is the ratio of the Value added (in %) of United States in 1987 to that in 1988?
Your response must be concise. 1.06. What is the ratio of the Value added (in %) in Kenya in 1987 to that in 1989?
Offer a terse response. 1.09. What is the ratio of the Value added (in %) in Malawi in 1987 to that in 1989?
Provide a succinct answer. 0.68. What is the ratio of the Value added (in %) in Syrian Arab Republic in 1987 to that in 1989?
Make the answer very short. 0.89. What is the ratio of the Value added (in %) of United States in 1987 to that in 1989?
Give a very brief answer. 1.09. What is the ratio of the Value added (in %) in Kenya in 1988 to that in 1989?
Keep it short and to the point. 1.04. What is the ratio of the Value added (in %) in Malawi in 1988 to that in 1989?
Provide a succinct answer. 0.95. What is the ratio of the Value added (in %) of Syrian Arab Republic in 1988 to that in 1989?
Give a very brief answer. 0.92. What is the ratio of the Value added (in %) in United States in 1988 to that in 1989?
Ensure brevity in your answer.  1.02. What is the difference between the highest and the second highest Value added (in %) in Kenya?
Keep it short and to the point. 0.07. What is the difference between the highest and the second highest Value added (in %) of Malawi?
Your answer should be compact. 0.92. What is the difference between the highest and the second highest Value added (in %) in Syrian Arab Republic?
Ensure brevity in your answer.  2.35. What is the difference between the highest and the second highest Value added (in %) of United States?
Your response must be concise. 0.26. What is the difference between the highest and the lowest Value added (in %) of Kenya?
Offer a very short reply. 0.91. What is the difference between the highest and the lowest Value added (in %) of Malawi?
Your response must be concise. 6.33. What is the difference between the highest and the lowest Value added (in %) of Syrian Arab Republic?
Your response must be concise. 15.2. What is the difference between the highest and the lowest Value added (in %) in United States?
Give a very brief answer. 0.7. 